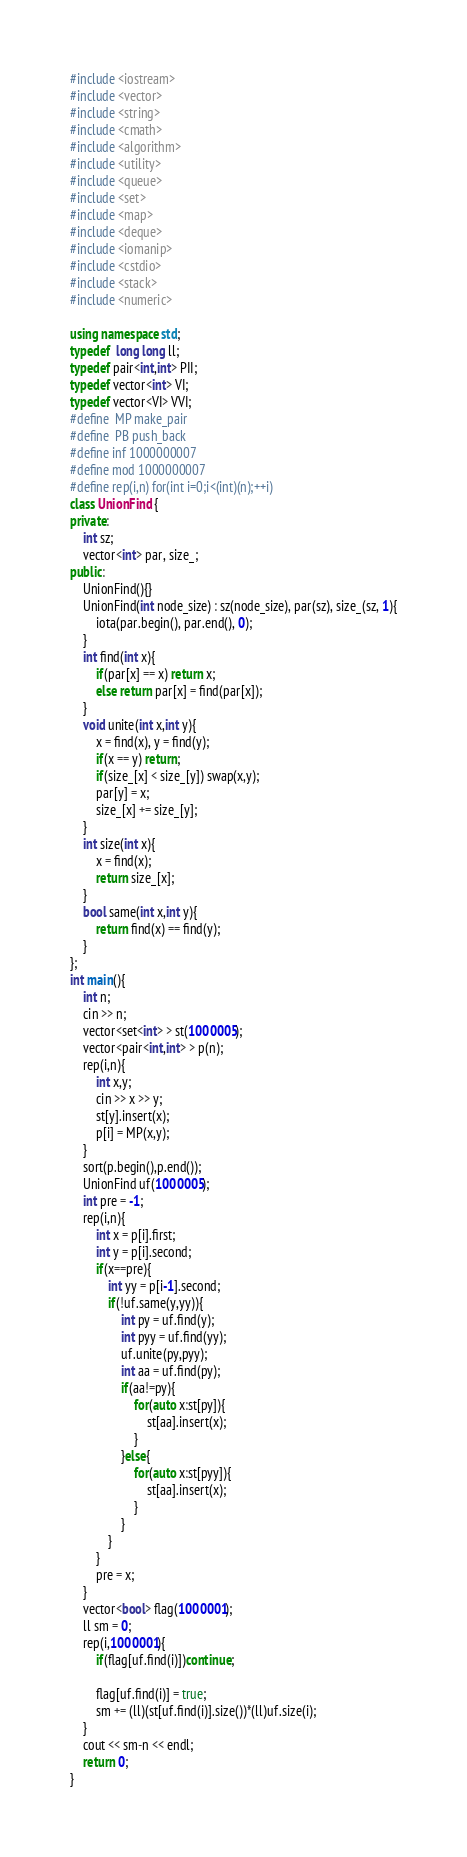Convert code to text. <code><loc_0><loc_0><loc_500><loc_500><_C++_>#include <iostream>
#include <vector>
#include <string>
#include <cmath>
#include <algorithm>
#include <utility>
#include <queue>
#include <set>
#include <map>
#include <deque>
#include <iomanip>
#include <cstdio>
#include <stack>
#include <numeric>

using namespace std;
typedef  long long ll;
typedef pair<int,int> PII;
typedef vector<int> VI;
typedef vector<VI> VVI;
#define  MP make_pair
#define  PB push_back
#define inf 1000000007
#define mod 1000000007
#define rep(i,n) for(int i=0;i<(int)(n);++i)
class UnionFind {
private:
    int sz;
    vector<int> par, size_;
public:
    UnionFind(){}
    UnionFind(int node_size) : sz(node_size), par(sz), size_(sz, 1){
        iota(par.begin(), par.end(), 0);
    }
    int find(int x){
        if(par[x] == x) return x;
        else return par[x] = find(par[x]);
    }
    void unite(int x,int y){
        x = find(x), y = find(y);
        if(x == y) return;
        if(size_[x] < size_[y]) swap(x,y);
        par[y] = x;
        size_[x] += size_[y];
    }
    int size(int x){
        x = find(x);
        return size_[x];
    }
    bool same(int x,int y){
        return find(x) == find(y);
    }
};
int main(){
    int n;
    cin >> n;
    vector<set<int> > st(1000005);
    vector<pair<int,int> > p(n);
    rep(i,n){
        int x,y;
        cin >> x >> y;
        st[y].insert(x);
        p[i] = MP(x,y);
    }
    sort(p.begin(),p.end());
    UnionFind uf(1000005);
    int pre = -1;
    rep(i,n){
        int x = p[i].first;
        int y = p[i].second;
        if(x==pre){
            int yy = p[i-1].second;
            if(!uf.same(y,yy)){
                int py = uf.find(y);
                int pyy = uf.find(yy);
                uf.unite(py,pyy);
                int aa = uf.find(py);
                if(aa!=py){
                    for(auto x:st[py]){
                        st[aa].insert(x);
                    }
                }else{
                    for(auto x:st[pyy]){
                        st[aa].insert(x);
                    }
                }
            }
        }
        pre = x;
    }
    vector<bool> flag(1000001);
    ll sm = 0;
    rep(i,1000001){
        if(flag[uf.find(i)])continue;

        flag[uf.find(i)] = true;
        sm += (ll)(st[uf.find(i)].size())*(ll)uf.size(i);
    }
    cout << sm-n << endl;
    return 0;
}</code> 